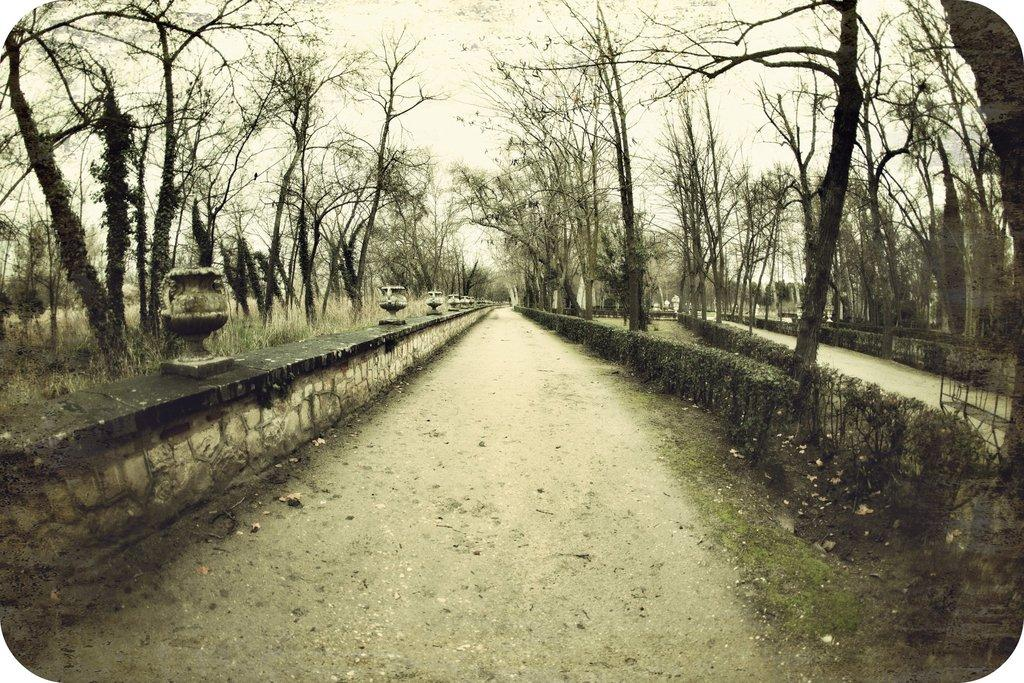What type of natural elements can be seen in the image? There are trees in the image. What type of structures are on the wall in the image? There are statues on the wall in the image. What type of pathway is visible in the image? There is a road in the image. What is visible in the background of the image? The sky is visible in the background of the image. What type of organization is responsible for maintaining the connection between the trees in the image? There is no mention of a connection between the trees in the image, nor is there any indication of an organization responsible for maintaining it. 